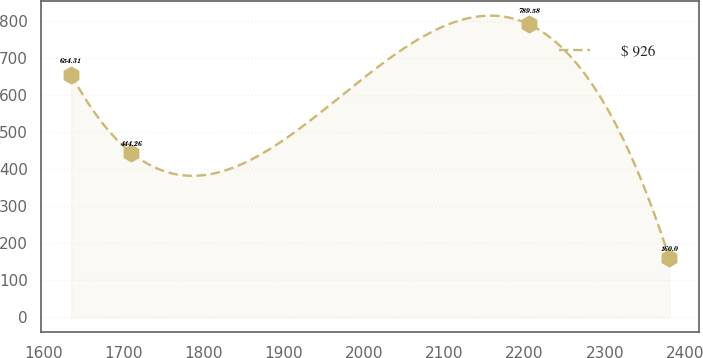<chart> <loc_0><loc_0><loc_500><loc_500><line_chart><ecel><fcel>$ 926<nl><fcel>1634.62<fcel>654.31<nl><fcel>1709.21<fcel>444.26<nl><fcel>2205.63<fcel>789.58<nl><fcel>2380.5<fcel>160<nl></chart> 